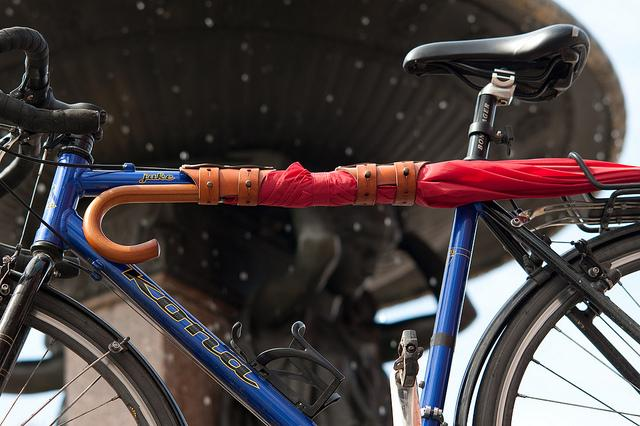What color is the umbrella strapped onto the bicycle frame's center bar? red 